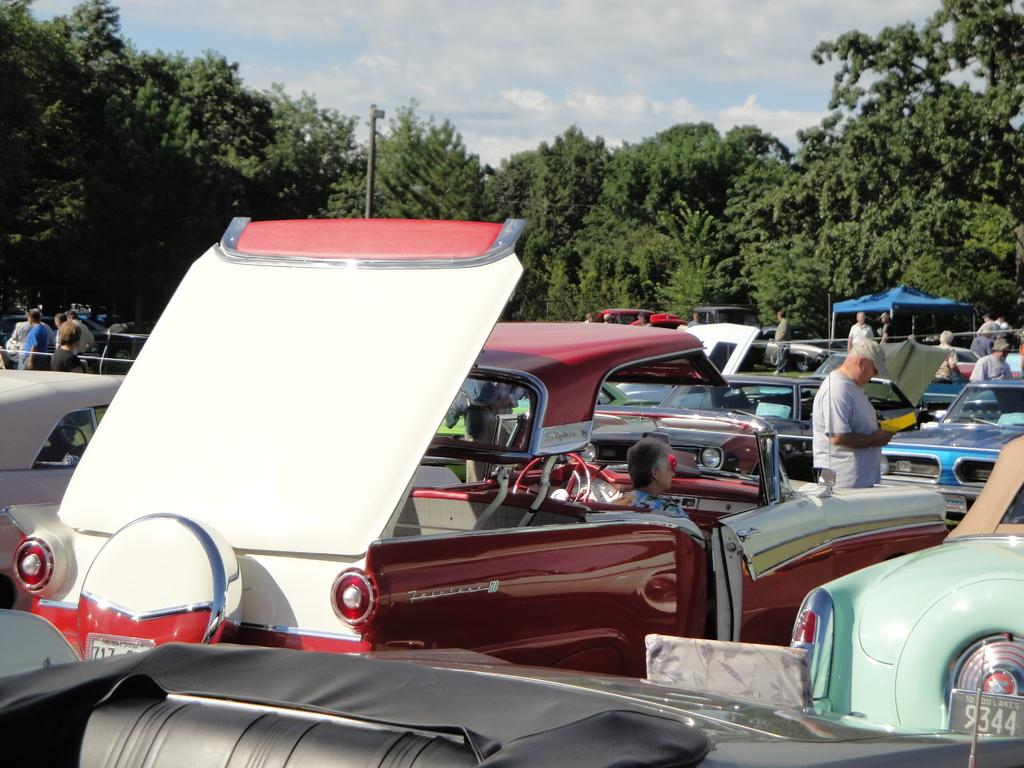What types of vehicles are in the image? There are motor vehicles in the image. What are the people in the image doing? There are persons standing on the floor in the image. What type of temporary shelter is present in the image? There are tents in the image. What type of natural vegetation is present in the image? There are trees in the image. What structure is present in the image? There is a pole in the image. What is visible in the sky in the image? The sky is visible in the image, and clouds are present in the sky. What type of house is visible in the image? There is no house present in the image; it features motor vehicles, persons, tents, trees, a pole, and a sky with clouds. How many oranges are hanging from the trees in the image? There are no oranges present in the image; it only features trees as a type of natural vegetation. 